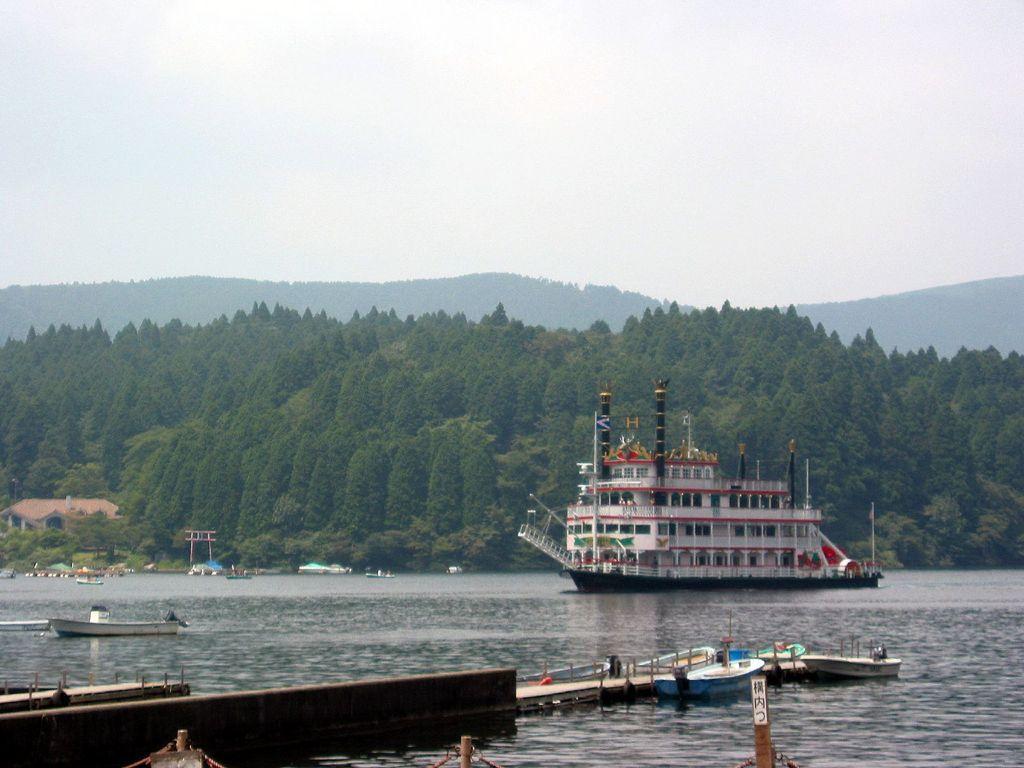Please provide a concise description of this image. In this picture we can see boats and a ship on the water, building, trees, mountains, some objects and in the background we can see the sky. 